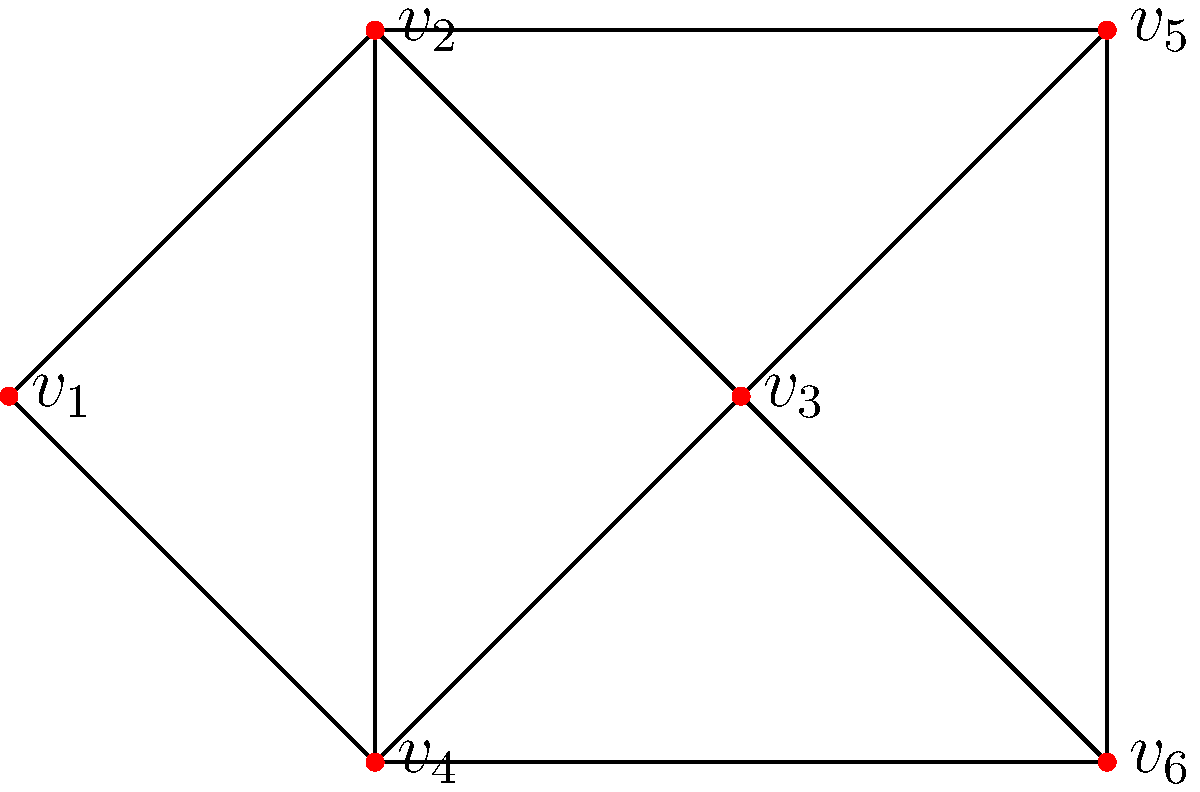In a network segmentation strategy, different security zones need to be represented by different colors in the graph above. What is the minimum number of colors required to ensure that no two adjacent vertices (directly connected security zones) have the same color, while maintaining strict separation between zones for maximum security? To determine the minimum number of colors required, we need to analyze the graph and find its chromatic number. The chromatic number is the smallest number of colors needed to color the vertices of a graph such that no two adjacent vertices share the same color. Let's approach this step-by-step:

1. Observe the graph structure:
   - The graph has 6 vertices ($v_1$ to $v_6$).
   - There are multiple connections between vertices, forming a complex network.

2. Identify the maximum clique:
   - A clique is a subset of vertices where every two vertices are adjacent.
   - The largest clique in this graph is a triangle (e.g., $v_1$, $v_2$, $v_4$).

3. Determine the lower bound:
   - The size of the maximum clique gives us a lower bound for the chromatic number.
   - In this case, it's 3, as the triangle requires at least 3 colors.

4. Attempt to color the graph with 3 colors:
   - Start with the triangle: Assign different colors to $v_1$, $v_2$, and $v_4$.
   - Continue with $v_3$: It's adjacent to $v_1$, $v_2$, and $v_4$, so it needs a fourth color.

5. Verify the need for a fourth color:
   - After assigning a fourth color to $v_3$, we can complete the coloring:
     - $v_5$ can use the same color as $v_1$ or $v_3$.
     - $v_6$ can use the same color as $v_1$ or $v_4$.

6. Confirm the minimum:
   - We've shown that 3 colors are not sufficient.
   - We've also demonstrated that 4 colors are enough to color the entire graph.

Therefore, the minimum number of colors required is 4. This ensures that no two adjacent security zones have the same color, maintaining strict separation for maximum security in the network segmentation strategy.
Answer: 4 colors 